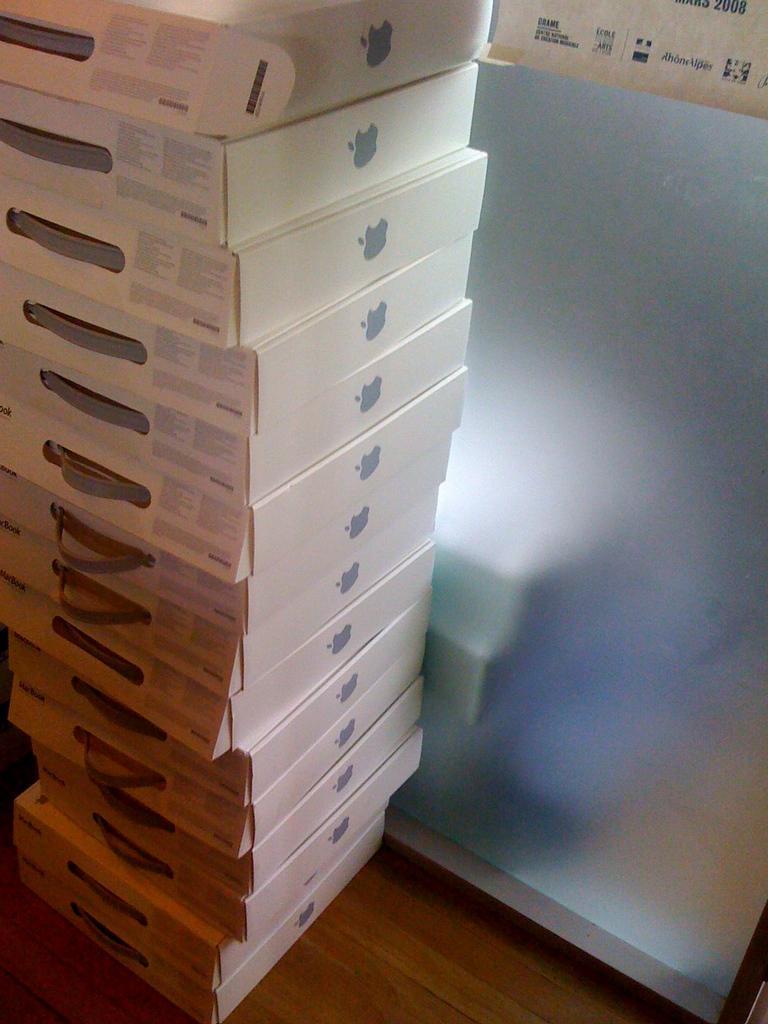Please provide a concise description of this image. In this picture we can see few boxes. 